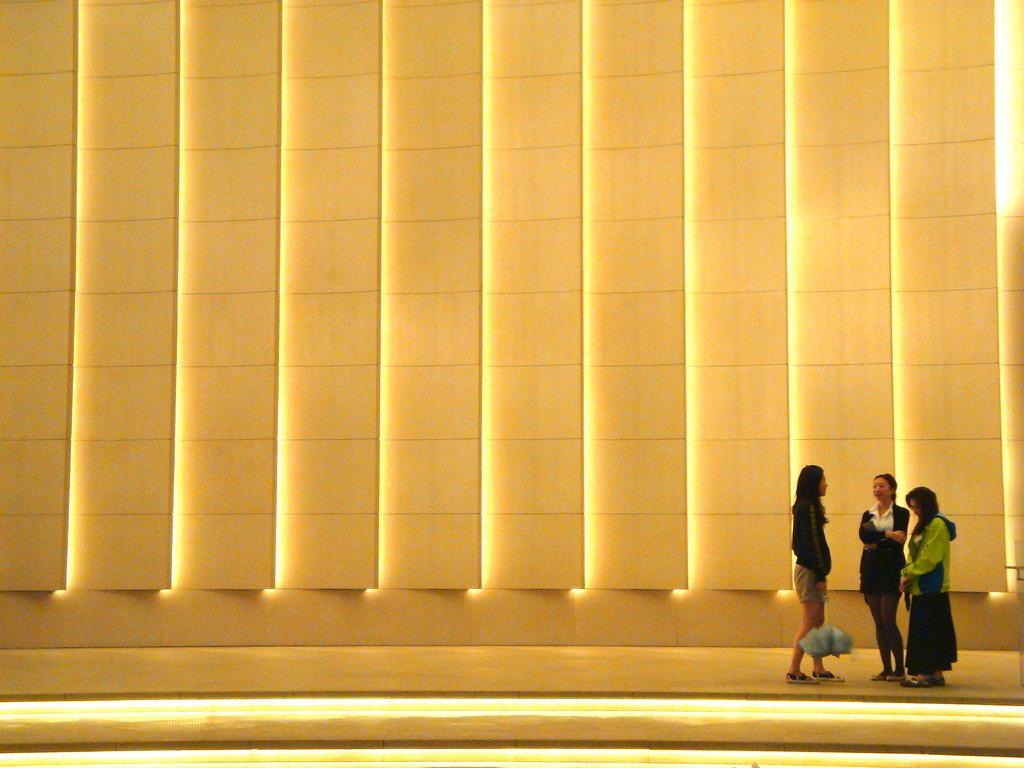Please provide a concise description of this image. In this image I can see three women are standing. I can see two of them are wearing black colour dress. I can also see yellow colour wall in background. 